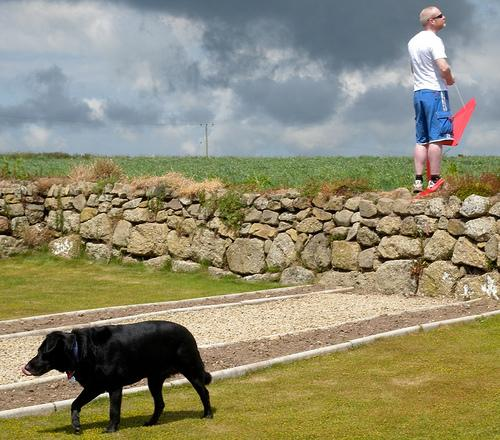What is the flag made of?

Choices:
A) cloth
B) leather
C) plastic
D) rayon plastic 